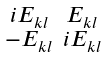<formula> <loc_0><loc_0><loc_500><loc_500>\begin{smallmatrix} i E _ { k l } & E _ { k l } \\ - E _ { k l } & i E _ { k l } \end{smallmatrix}</formula> 